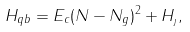<formula> <loc_0><loc_0><loc_500><loc_500>H _ { q b } = E _ { c } ( N - N _ { g } ) ^ { 2 } + H _ { _ { J } } ,</formula> 